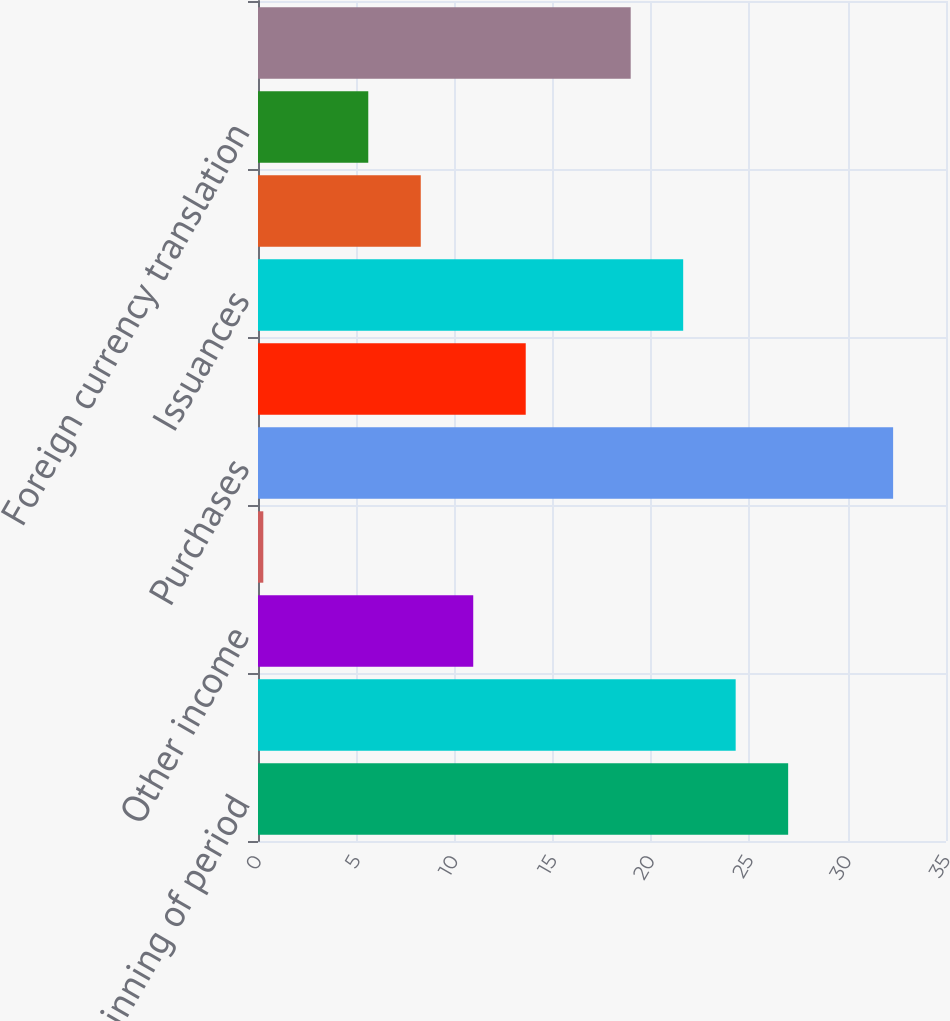Convert chart. <chart><loc_0><loc_0><loc_500><loc_500><bar_chart><fcel>Fair Value beginning of period<fcel>Realized investment gains<fcel>Other income<fcel>Net investment income<fcel>Purchases<fcel>Sales<fcel>Issuances<fcel>Settlements<fcel>Foreign currency translation<fcel>Other(1)<nl><fcel>26.97<fcel>24.3<fcel>10.95<fcel>0.27<fcel>32.31<fcel>13.62<fcel>21.63<fcel>8.28<fcel>5.61<fcel>18.96<nl></chart> 